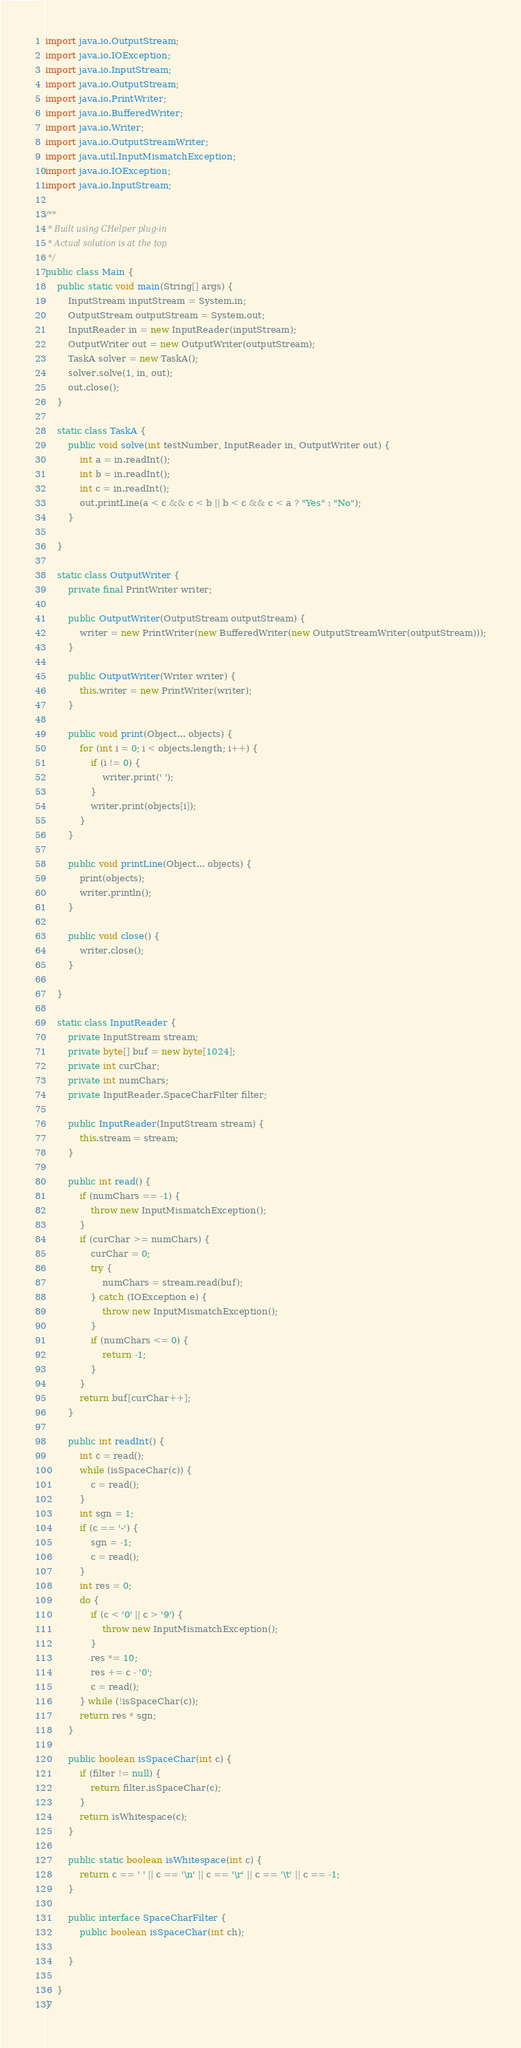<code> <loc_0><loc_0><loc_500><loc_500><_Java_>import java.io.OutputStream;
import java.io.IOException;
import java.io.InputStream;
import java.io.OutputStream;
import java.io.PrintWriter;
import java.io.BufferedWriter;
import java.io.Writer;
import java.io.OutputStreamWriter;
import java.util.InputMismatchException;
import java.io.IOException;
import java.io.InputStream;

/**
 * Built using CHelper plug-in
 * Actual solution is at the top
 */
public class Main {
    public static void main(String[] args) {
        InputStream inputStream = System.in;
        OutputStream outputStream = System.out;
        InputReader in = new InputReader(inputStream);
        OutputWriter out = new OutputWriter(outputStream);
        TaskA solver = new TaskA();
        solver.solve(1, in, out);
        out.close();
    }

    static class TaskA {
        public void solve(int testNumber, InputReader in, OutputWriter out) {
            int a = in.readInt();
            int b = in.readInt();
            int c = in.readInt();
            out.printLine(a < c && c < b || b < c && c < a ? "Yes" : "No");
        }

    }

    static class OutputWriter {
        private final PrintWriter writer;

        public OutputWriter(OutputStream outputStream) {
            writer = new PrintWriter(new BufferedWriter(new OutputStreamWriter(outputStream)));
        }

        public OutputWriter(Writer writer) {
            this.writer = new PrintWriter(writer);
        }

        public void print(Object... objects) {
            for (int i = 0; i < objects.length; i++) {
                if (i != 0) {
                    writer.print(' ');
                }
                writer.print(objects[i]);
            }
        }

        public void printLine(Object... objects) {
            print(objects);
            writer.println();
        }

        public void close() {
            writer.close();
        }

    }

    static class InputReader {
        private InputStream stream;
        private byte[] buf = new byte[1024];
        private int curChar;
        private int numChars;
        private InputReader.SpaceCharFilter filter;

        public InputReader(InputStream stream) {
            this.stream = stream;
        }

        public int read() {
            if (numChars == -1) {
                throw new InputMismatchException();
            }
            if (curChar >= numChars) {
                curChar = 0;
                try {
                    numChars = stream.read(buf);
                } catch (IOException e) {
                    throw new InputMismatchException();
                }
                if (numChars <= 0) {
                    return -1;
                }
            }
            return buf[curChar++];
        }

        public int readInt() {
            int c = read();
            while (isSpaceChar(c)) {
                c = read();
            }
            int sgn = 1;
            if (c == '-') {
                sgn = -1;
                c = read();
            }
            int res = 0;
            do {
                if (c < '0' || c > '9') {
                    throw new InputMismatchException();
                }
                res *= 10;
                res += c - '0';
                c = read();
            } while (!isSpaceChar(c));
            return res * sgn;
        }

        public boolean isSpaceChar(int c) {
            if (filter != null) {
                return filter.isSpaceChar(c);
            }
            return isWhitespace(c);
        }

        public static boolean isWhitespace(int c) {
            return c == ' ' || c == '\n' || c == '\r' || c == '\t' || c == -1;
        }

        public interface SpaceCharFilter {
            public boolean isSpaceChar(int ch);

        }

    }
}

</code> 